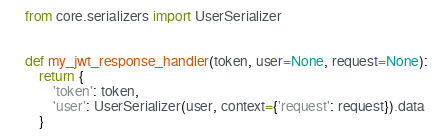Convert code to text. <code><loc_0><loc_0><loc_500><loc_500><_Python_>from core.serializers import UserSerializer


def my_jwt_response_handler(token, user=None, request=None):
    return {
        'token': token,
        'user': UserSerializer(user, context={'request': request}).data
    }</code> 